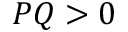<formula> <loc_0><loc_0><loc_500><loc_500>P Q > 0</formula> 